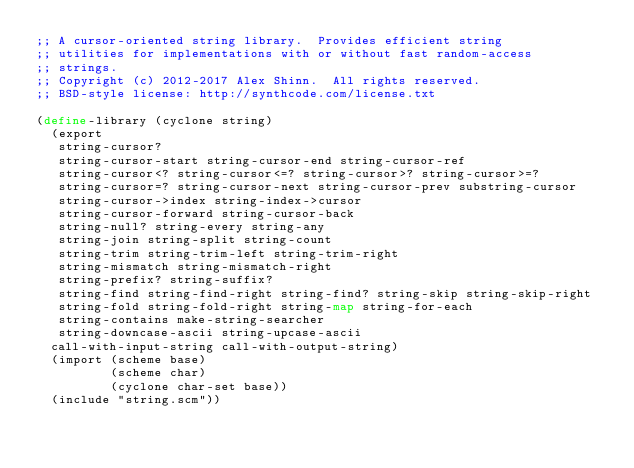Convert code to text. <code><loc_0><loc_0><loc_500><loc_500><_Scheme_>;; A cursor-oriented string library.  Provides efficient string
;; utilities for implementations with or without fast random-access
;; strings.
;; Copyright (c) 2012-2017 Alex Shinn.  All rights reserved.
;; BSD-style license: http://synthcode.com/license.txt

(define-library (cyclone string)
  (export
   string-cursor?
   string-cursor-start string-cursor-end string-cursor-ref
   string-cursor<? string-cursor<=? string-cursor>? string-cursor>=?
   string-cursor=? string-cursor-next string-cursor-prev substring-cursor
   string-cursor->index string-index->cursor
   string-cursor-forward string-cursor-back
   string-null? string-every string-any
   string-join string-split string-count
   string-trim string-trim-left string-trim-right
   string-mismatch string-mismatch-right
   string-prefix? string-suffix?
   string-find string-find-right string-find? string-skip string-skip-right
   string-fold string-fold-right string-map string-for-each
   string-contains make-string-searcher
   string-downcase-ascii string-upcase-ascii
  call-with-input-string call-with-output-string)
  (import (scheme base)
          (scheme char)
          (cyclone char-set base))
  (include "string.scm"))
</code> 